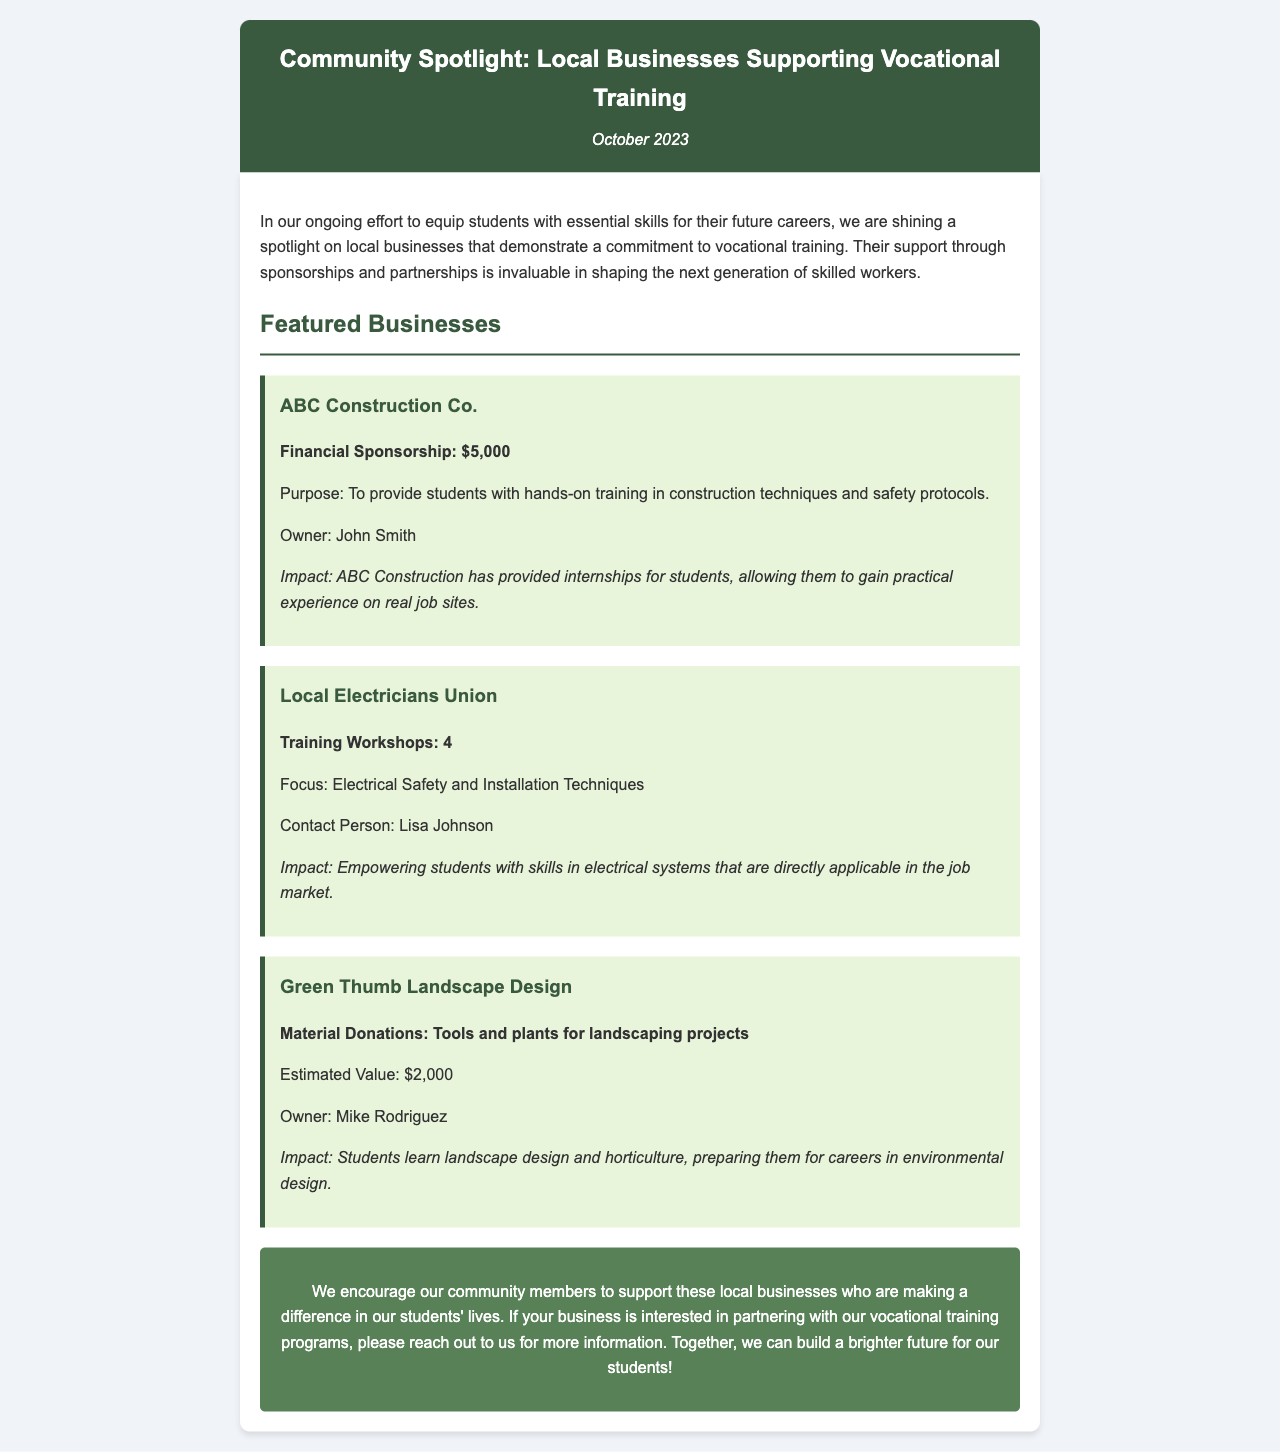what is the title of the newsletter? The title is prominently displayed in the header section of the document.
Answer: Community Spotlight: Local Businesses Supporting Vocational Training who is the owner of Green Thumb Landscape Design? The owner's name is listed under the business section for Green Thumb Landscape Design.
Answer: Mike Rodriguez how much financial sponsorship did ABC Construction Co. provide? The sponsorship amount is specified in the description for ABC Construction Co.
Answer: $5,000 what type of training workshops did the Local Electricians Union offer? The document specifies the focus of the workshops under the Local Electricians Union's section.
Answer: Electrical Safety and Installation Techniques what is the total estimated value of material donations from Green Thumb Landscape Design? The estimated value is mentioned under the business section for Green Thumb Landscape Design.
Answer: $2,000 what impact did ABC Construction Co. have on students? The impact is described in the impact section for ABC Construction Co. and mentions the type of experience provided to students.
Answer: Provided internships for students how many training workshops did the Local Electricians Union conduct? The number of training workshops is explicitly mentioned in the document.
Answer: 4 what is the primary purpose of the newsletter? The purpose is stated at the beginning of the content section, highlighting the focus on local businesses and vocational training.
Answer: To equip students with essential skills for their future careers 